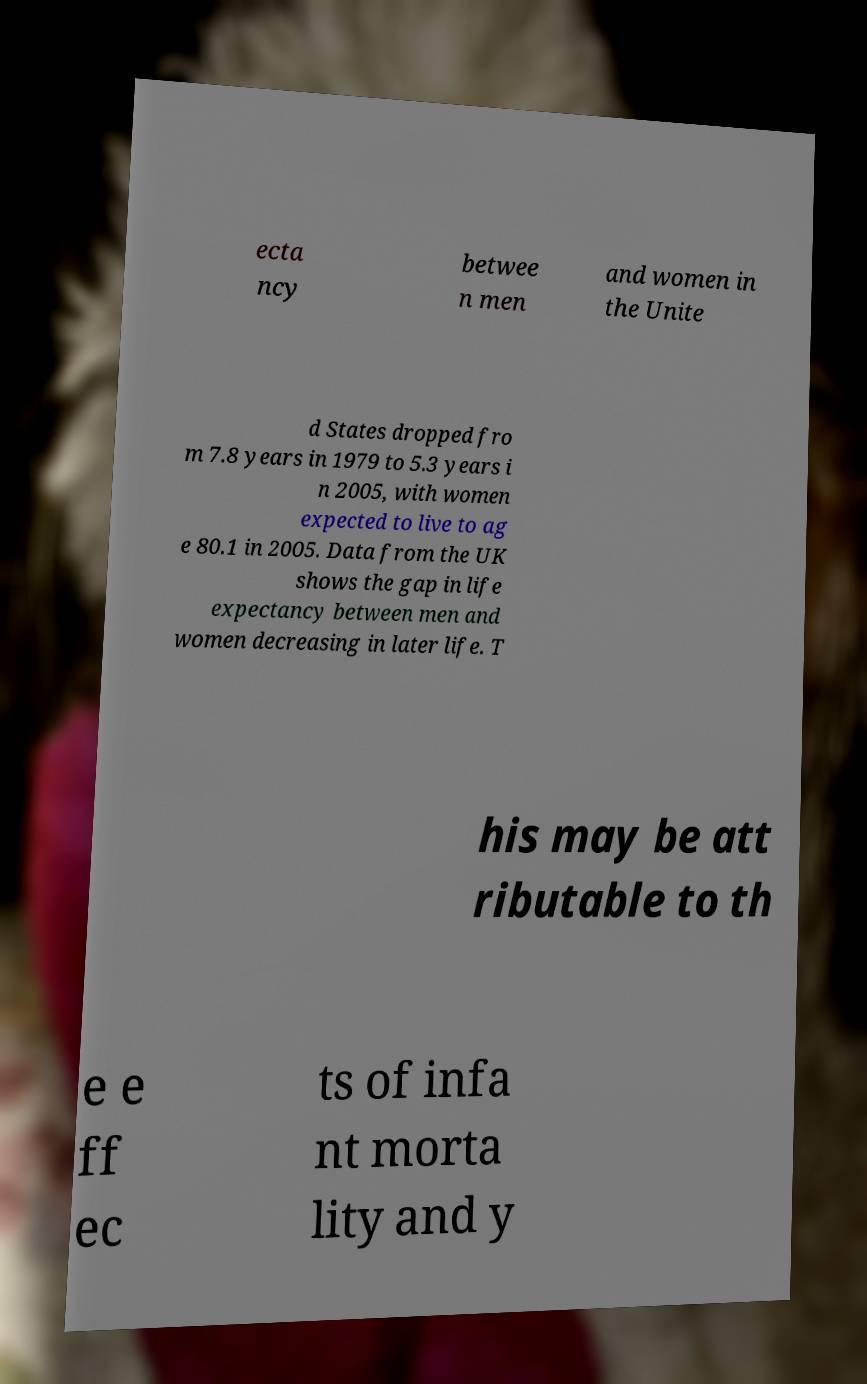Could you extract and type out the text from this image? ecta ncy betwee n men and women in the Unite d States dropped fro m 7.8 years in 1979 to 5.3 years i n 2005, with women expected to live to ag e 80.1 in 2005. Data from the UK shows the gap in life expectancy between men and women decreasing in later life. T his may be att ributable to th e e ff ec ts of infa nt morta lity and y 